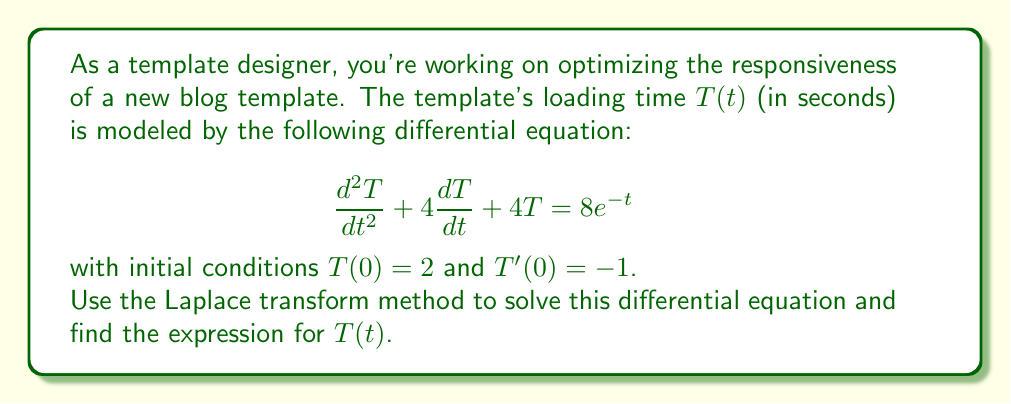Can you answer this question? Let's solve this step-by-step using the Laplace transform method:

1) First, let's take the Laplace transform of both sides of the equation. Let $\mathcal{L}\{T(t)\} = X(s)$.

   $$\mathcal{L}\{\frac{d^2T}{dt^2} + 4\frac{dT}{dt} + 4T\} = \mathcal{L}\{8e^{-t}\}$$

2) Using Laplace transform properties:

   $$s^2X(s) - sT(0) - T'(0) + 4[sX(s) - T(0)] + 4X(s) = \frac{8}{s+1}$$

3) Substitute the initial conditions $T(0) = 2$ and $T'(0) = -1$:

   $$s^2X(s) - 2s + 1 + 4sX(s) - 8 + 4X(s) = \frac{8}{s+1}$$

4) Simplify:

   $$(s^2 + 4s + 4)X(s) = \frac{8}{s+1} + 2s - 1 + 8$$

   $$(s^2 + 4s + 4)X(s) = \frac{8}{s+1} + 2s + 7$$

5) Solve for $X(s)$:

   $$X(s) = \frac{8}{(s+1)(s^2 + 4s + 4)} + \frac{2s + 7}{s^2 + 4s + 4}$$

6) Simplify the right side:

   $$X(s) = \frac{8}{(s+1)(s+2)^2} + \frac{2s + 7}{(s+2)^2}$$

7) Use partial fraction decomposition:

   $$X(s) = \frac{A}{s+1} + \frac{B}{s+2} + \frac{C}{(s+2)^2} + \frac{2s + 7}{(s+2)^2}$$

   Solving for $A$, $B$, and $C$:

   $$A = -4, B = 4, C = 0$$

8) Therefore:

   $$X(s) = \frac{-4}{s+1} + \frac{4}{s+2} + \frac{2s + 7}{(s+2)^2}$$

9) Now, take the inverse Laplace transform:

   $$T(t) = -4e^{-t} + 4e^{-2t} + (2t + 3)e^{-2t}$$

10) Simplify:

    $$T(t) = -4e^{-t} + (2t + 7)e^{-2t}$$
Answer: $T(t) = -4e^{-t} + (2t + 7)e^{-2t}$ 